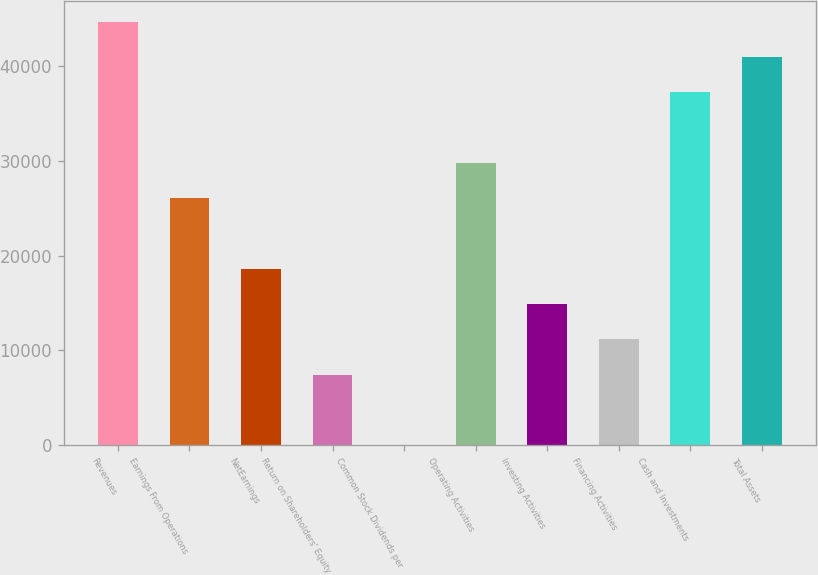<chart> <loc_0><loc_0><loc_500><loc_500><bar_chart><fcel>Revenues<fcel>Earnings From Operations<fcel>NetEarnings<fcel>Return on Shareholders' Equity<fcel>Common Stock Dividends per<fcel>Operating Activities<fcel>Investing Activities<fcel>Financing Activities<fcel>Cash and Investments<fcel>Total Assets<nl><fcel>44661.6<fcel>26052.6<fcel>18609<fcel>7443.61<fcel>0.01<fcel>29774.4<fcel>14887.2<fcel>11165.4<fcel>37218<fcel>40939.8<nl></chart> 